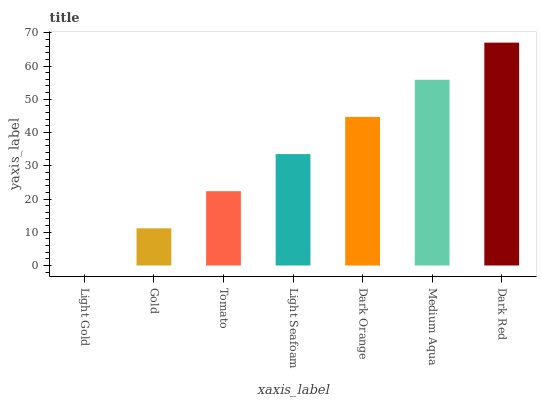Is Gold the minimum?
Answer yes or no. No. Is Gold the maximum?
Answer yes or no. No. Is Gold greater than Light Gold?
Answer yes or no. Yes. Is Light Gold less than Gold?
Answer yes or no. Yes. Is Light Gold greater than Gold?
Answer yes or no. No. Is Gold less than Light Gold?
Answer yes or no. No. Is Light Seafoam the high median?
Answer yes or no. Yes. Is Light Seafoam the low median?
Answer yes or no. Yes. Is Medium Aqua the high median?
Answer yes or no. No. Is Tomato the low median?
Answer yes or no. No. 